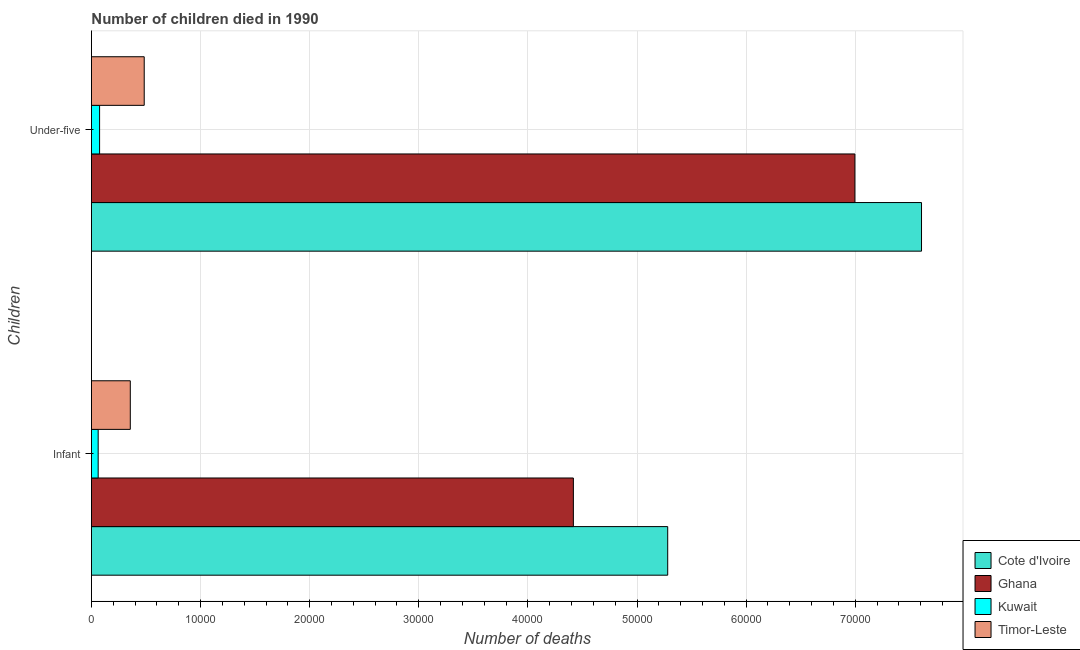How many different coloured bars are there?
Provide a short and direct response. 4. How many groups of bars are there?
Give a very brief answer. 2. Are the number of bars per tick equal to the number of legend labels?
Offer a terse response. Yes. How many bars are there on the 2nd tick from the top?
Keep it short and to the point. 4. How many bars are there on the 1st tick from the bottom?
Your answer should be compact. 4. What is the label of the 2nd group of bars from the top?
Provide a succinct answer. Infant. What is the number of infant deaths in Kuwait?
Your response must be concise. 618. Across all countries, what is the maximum number of infant deaths?
Ensure brevity in your answer.  5.28e+04. Across all countries, what is the minimum number of infant deaths?
Provide a short and direct response. 618. In which country was the number of under-five deaths maximum?
Ensure brevity in your answer.  Cote d'Ivoire. In which country was the number of infant deaths minimum?
Your answer should be compact. Kuwait. What is the total number of under-five deaths in the graph?
Your answer should be very brief. 1.52e+05. What is the difference between the number of infant deaths in Ghana and that in Kuwait?
Your answer should be very brief. 4.36e+04. What is the difference between the number of infant deaths in Cote d'Ivoire and the number of under-five deaths in Ghana?
Give a very brief answer. -1.72e+04. What is the average number of under-five deaths per country?
Offer a very short reply. 3.79e+04. What is the difference between the number of infant deaths and number of under-five deaths in Timor-Leste?
Make the answer very short. -1276. What is the ratio of the number of infant deaths in Ghana to that in Cote d'Ivoire?
Give a very brief answer. 0.84. What does the 1st bar from the top in Infant represents?
Ensure brevity in your answer.  Timor-Leste. How many bars are there?
Offer a very short reply. 8. How many countries are there in the graph?
Give a very brief answer. 4. Where does the legend appear in the graph?
Provide a succinct answer. Bottom right. What is the title of the graph?
Ensure brevity in your answer.  Number of children died in 1990. Does "Zimbabwe" appear as one of the legend labels in the graph?
Offer a terse response. No. What is the label or title of the X-axis?
Make the answer very short. Number of deaths. What is the label or title of the Y-axis?
Keep it short and to the point. Children. What is the Number of deaths in Cote d'Ivoire in Infant?
Offer a terse response. 5.28e+04. What is the Number of deaths of Ghana in Infant?
Ensure brevity in your answer.  4.42e+04. What is the Number of deaths in Kuwait in Infant?
Your response must be concise. 618. What is the Number of deaths of Timor-Leste in Infant?
Provide a short and direct response. 3562. What is the Number of deaths of Cote d'Ivoire in Under-five?
Offer a terse response. 7.61e+04. What is the Number of deaths of Ghana in Under-five?
Ensure brevity in your answer.  7.00e+04. What is the Number of deaths of Kuwait in Under-five?
Your answer should be compact. 749. What is the Number of deaths in Timor-Leste in Under-five?
Offer a terse response. 4838. Across all Children, what is the maximum Number of deaths in Cote d'Ivoire?
Give a very brief answer. 7.61e+04. Across all Children, what is the maximum Number of deaths in Ghana?
Make the answer very short. 7.00e+04. Across all Children, what is the maximum Number of deaths of Kuwait?
Provide a succinct answer. 749. Across all Children, what is the maximum Number of deaths in Timor-Leste?
Keep it short and to the point. 4838. Across all Children, what is the minimum Number of deaths in Cote d'Ivoire?
Make the answer very short. 5.28e+04. Across all Children, what is the minimum Number of deaths of Ghana?
Keep it short and to the point. 4.42e+04. Across all Children, what is the minimum Number of deaths in Kuwait?
Ensure brevity in your answer.  618. Across all Children, what is the minimum Number of deaths of Timor-Leste?
Give a very brief answer. 3562. What is the total Number of deaths of Cote d'Ivoire in the graph?
Ensure brevity in your answer.  1.29e+05. What is the total Number of deaths in Ghana in the graph?
Your answer should be very brief. 1.14e+05. What is the total Number of deaths in Kuwait in the graph?
Offer a very short reply. 1367. What is the total Number of deaths of Timor-Leste in the graph?
Provide a short and direct response. 8400. What is the difference between the Number of deaths in Cote d'Ivoire in Infant and that in Under-five?
Your answer should be very brief. -2.33e+04. What is the difference between the Number of deaths of Ghana in Infant and that in Under-five?
Ensure brevity in your answer.  -2.58e+04. What is the difference between the Number of deaths of Kuwait in Infant and that in Under-five?
Give a very brief answer. -131. What is the difference between the Number of deaths of Timor-Leste in Infant and that in Under-five?
Provide a short and direct response. -1276. What is the difference between the Number of deaths in Cote d'Ivoire in Infant and the Number of deaths in Ghana in Under-five?
Ensure brevity in your answer.  -1.72e+04. What is the difference between the Number of deaths of Cote d'Ivoire in Infant and the Number of deaths of Kuwait in Under-five?
Keep it short and to the point. 5.21e+04. What is the difference between the Number of deaths of Cote d'Ivoire in Infant and the Number of deaths of Timor-Leste in Under-five?
Make the answer very short. 4.80e+04. What is the difference between the Number of deaths of Ghana in Infant and the Number of deaths of Kuwait in Under-five?
Offer a very short reply. 4.34e+04. What is the difference between the Number of deaths in Ghana in Infant and the Number of deaths in Timor-Leste in Under-five?
Provide a short and direct response. 3.93e+04. What is the difference between the Number of deaths in Kuwait in Infant and the Number of deaths in Timor-Leste in Under-five?
Give a very brief answer. -4220. What is the average Number of deaths in Cote d'Ivoire per Children?
Your answer should be compact. 6.44e+04. What is the average Number of deaths in Ghana per Children?
Give a very brief answer. 5.71e+04. What is the average Number of deaths in Kuwait per Children?
Provide a succinct answer. 683.5. What is the average Number of deaths of Timor-Leste per Children?
Your answer should be very brief. 4200. What is the difference between the Number of deaths of Cote d'Ivoire and Number of deaths of Ghana in Infant?
Give a very brief answer. 8645. What is the difference between the Number of deaths in Cote d'Ivoire and Number of deaths in Kuwait in Infant?
Provide a succinct answer. 5.22e+04. What is the difference between the Number of deaths of Cote d'Ivoire and Number of deaths of Timor-Leste in Infant?
Provide a succinct answer. 4.93e+04. What is the difference between the Number of deaths of Ghana and Number of deaths of Kuwait in Infant?
Make the answer very short. 4.36e+04. What is the difference between the Number of deaths of Ghana and Number of deaths of Timor-Leste in Infant?
Make the answer very short. 4.06e+04. What is the difference between the Number of deaths of Kuwait and Number of deaths of Timor-Leste in Infant?
Ensure brevity in your answer.  -2944. What is the difference between the Number of deaths of Cote d'Ivoire and Number of deaths of Ghana in Under-five?
Your answer should be compact. 6105. What is the difference between the Number of deaths in Cote d'Ivoire and Number of deaths in Kuwait in Under-five?
Your answer should be very brief. 7.53e+04. What is the difference between the Number of deaths in Cote d'Ivoire and Number of deaths in Timor-Leste in Under-five?
Provide a succinct answer. 7.12e+04. What is the difference between the Number of deaths in Ghana and Number of deaths in Kuwait in Under-five?
Make the answer very short. 6.92e+04. What is the difference between the Number of deaths of Ghana and Number of deaths of Timor-Leste in Under-five?
Provide a succinct answer. 6.51e+04. What is the difference between the Number of deaths of Kuwait and Number of deaths of Timor-Leste in Under-five?
Give a very brief answer. -4089. What is the ratio of the Number of deaths in Cote d'Ivoire in Infant to that in Under-five?
Offer a terse response. 0.69. What is the ratio of the Number of deaths in Ghana in Infant to that in Under-five?
Your response must be concise. 0.63. What is the ratio of the Number of deaths in Kuwait in Infant to that in Under-five?
Offer a very short reply. 0.83. What is the ratio of the Number of deaths of Timor-Leste in Infant to that in Under-five?
Provide a short and direct response. 0.74. What is the difference between the highest and the second highest Number of deaths in Cote d'Ivoire?
Your answer should be compact. 2.33e+04. What is the difference between the highest and the second highest Number of deaths in Ghana?
Give a very brief answer. 2.58e+04. What is the difference between the highest and the second highest Number of deaths of Kuwait?
Provide a succinct answer. 131. What is the difference between the highest and the second highest Number of deaths of Timor-Leste?
Ensure brevity in your answer.  1276. What is the difference between the highest and the lowest Number of deaths of Cote d'Ivoire?
Provide a succinct answer. 2.33e+04. What is the difference between the highest and the lowest Number of deaths of Ghana?
Make the answer very short. 2.58e+04. What is the difference between the highest and the lowest Number of deaths in Kuwait?
Your answer should be compact. 131. What is the difference between the highest and the lowest Number of deaths of Timor-Leste?
Offer a very short reply. 1276. 